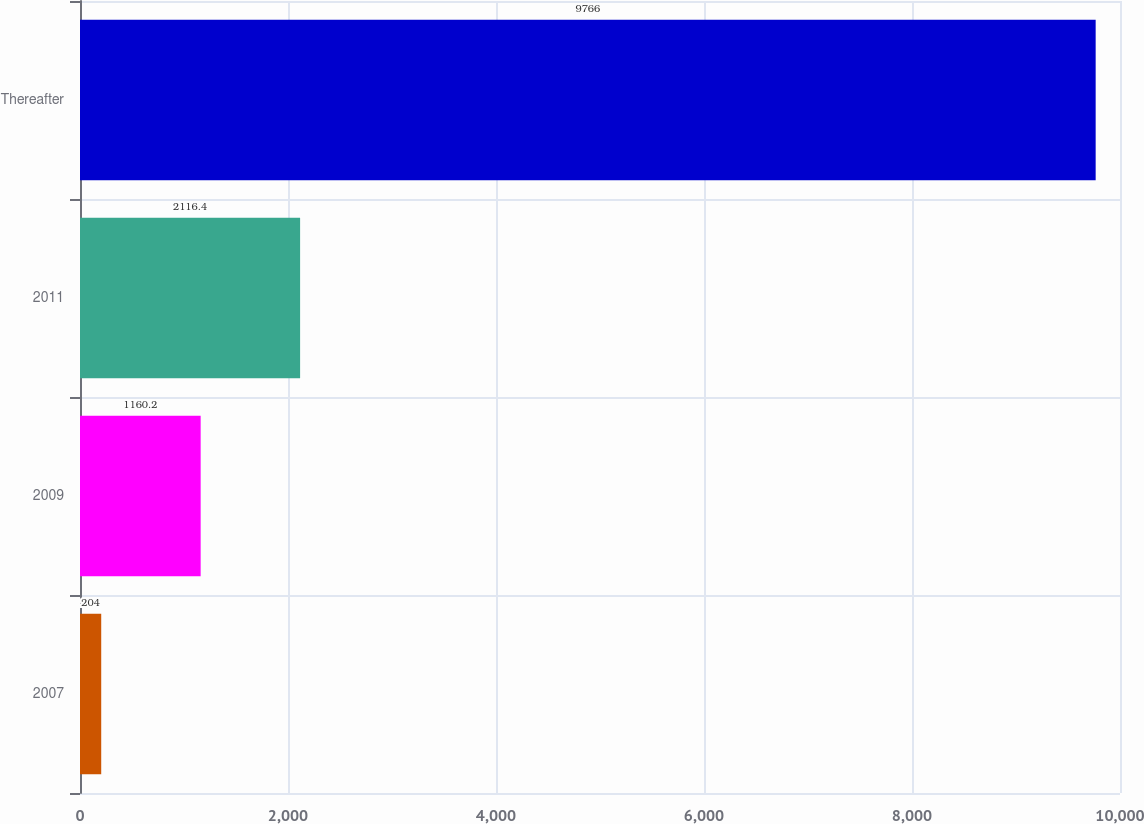Convert chart. <chart><loc_0><loc_0><loc_500><loc_500><bar_chart><fcel>2007<fcel>2009<fcel>2011<fcel>Thereafter<nl><fcel>204<fcel>1160.2<fcel>2116.4<fcel>9766<nl></chart> 